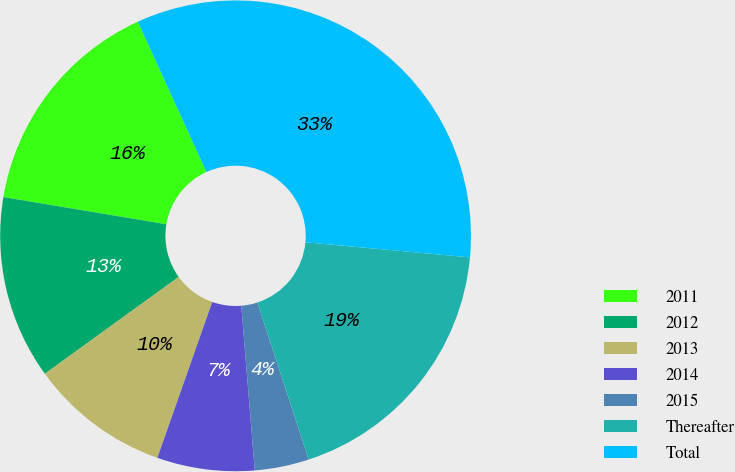Convert chart. <chart><loc_0><loc_0><loc_500><loc_500><pie_chart><fcel>2011<fcel>2012<fcel>2013<fcel>2014<fcel>2015<fcel>Thereafter<fcel>Total<nl><fcel>15.55%<fcel>12.6%<fcel>9.64%<fcel>6.69%<fcel>3.73%<fcel>18.51%<fcel>33.28%<nl></chart> 